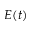Convert formula to latex. <formula><loc_0><loc_0><loc_500><loc_500>E ( t )</formula> 